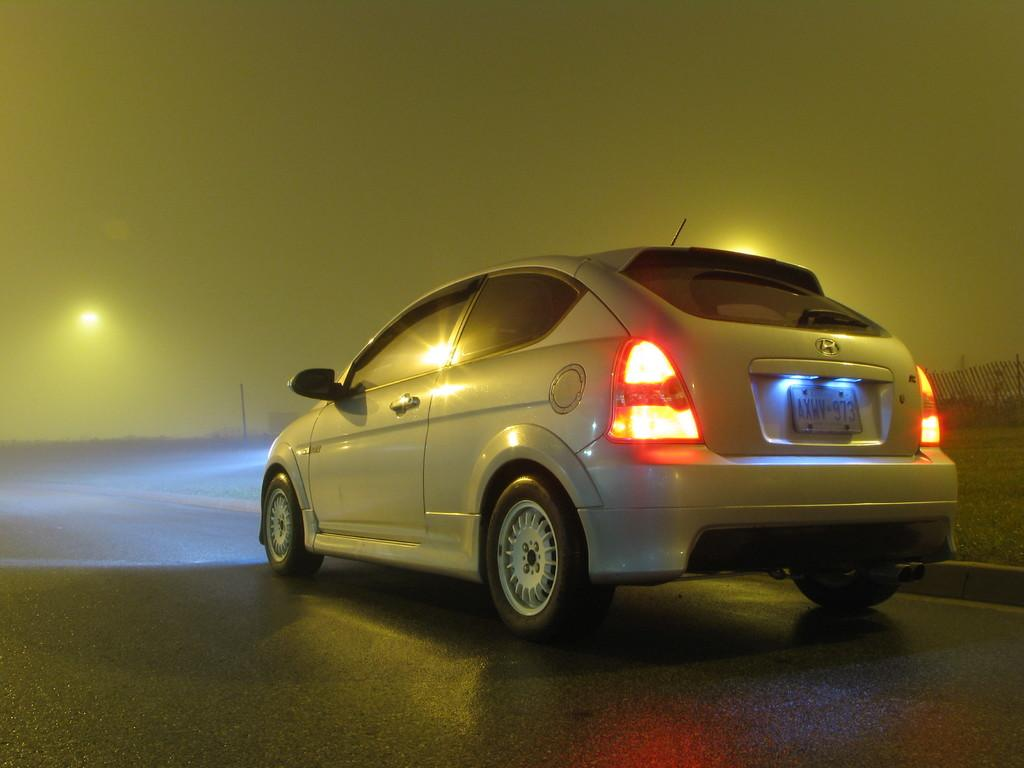<image>
Give a short and clear explanation of the subsequent image. A Honda car from the province of Ontario. 